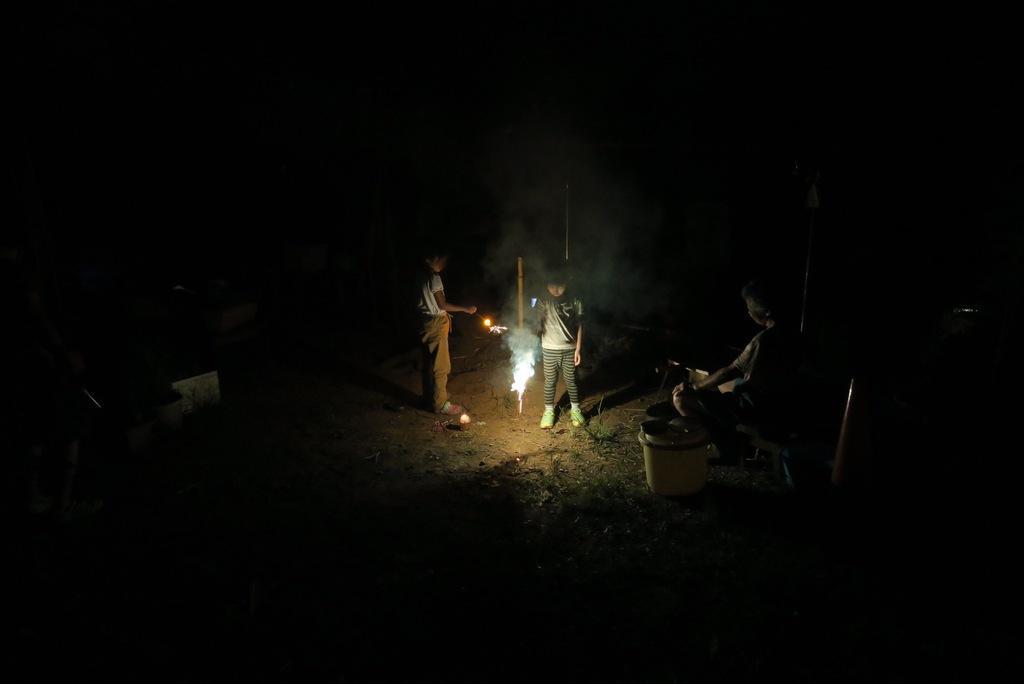Describe this image in one or two sentences. In this picture I can see people standing. I can see a person sitting on the chair. I can see fireworks. 